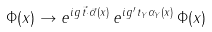Convert formula to latex. <formula><loc_0><loc_0><loc_500><loc_500>\Phi ( x ) \to e ^ { i g \, { \vec { t } } \cdot { \vec { \alpha } ( x ) } } \, e ^ { i g ^ { \prime } \, t _ { Y } \alpha _ { Y } ( x ) } \, \Phi ( x )</formula> 